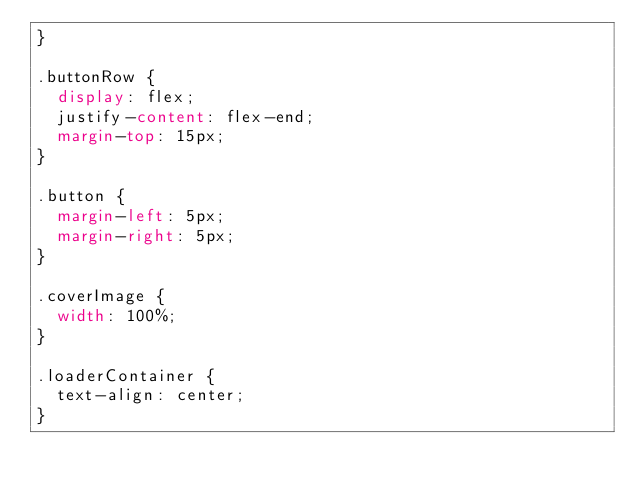<code> <loc_0><loc_0><loc_500><loc_500><_CSS_>}

.buttonRow {
  display: flex;
  justify-content: flex-end;
  margin-top: 15px;
}

.button {
  margin-left: 5px;
  margin-right: 5px;
}

.coverImage {
  width: 100%;
}

.loaderContainer {
  text-align: center;
}
</code> 